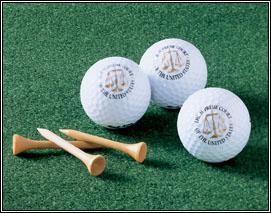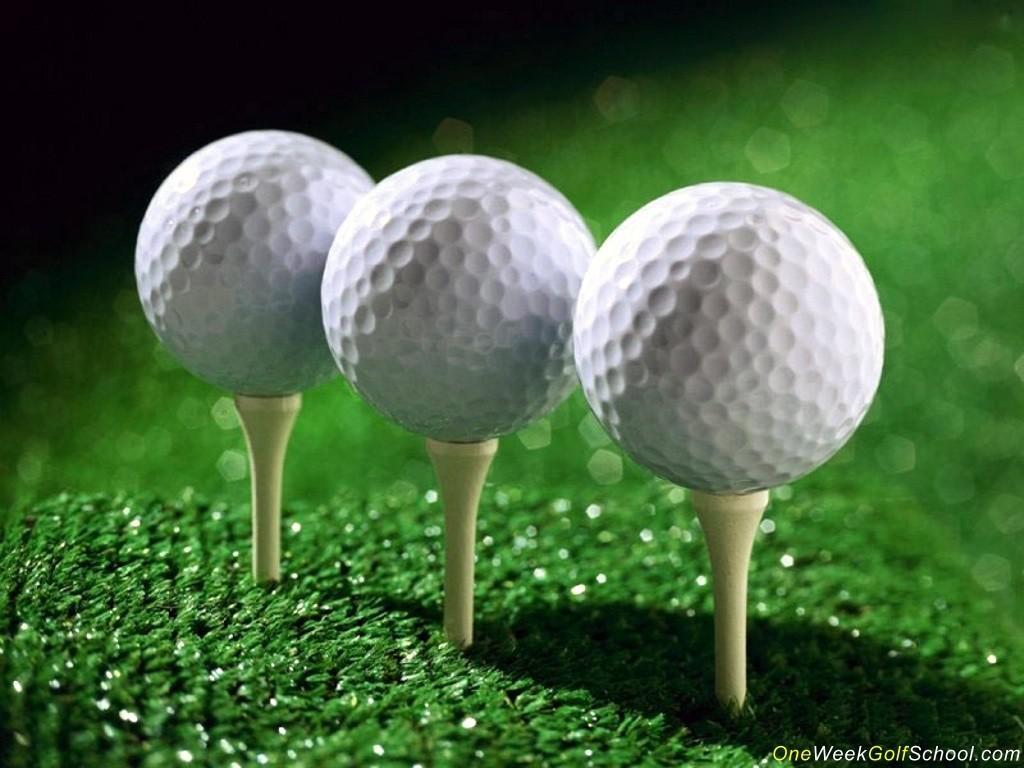The first image is the image on the left, the second image is the image on the right. Assess this claim about the two images: "An image shows at least one golf ball on the green ground near a hole.". Correct or not? Answer yes or no. No. The first image is the image on the left, the second image is the image on the right. Examine the images to the left and right. Is the description "The balls in the image on the left are on the grass." accurate? Answer yes or no. Yes. 